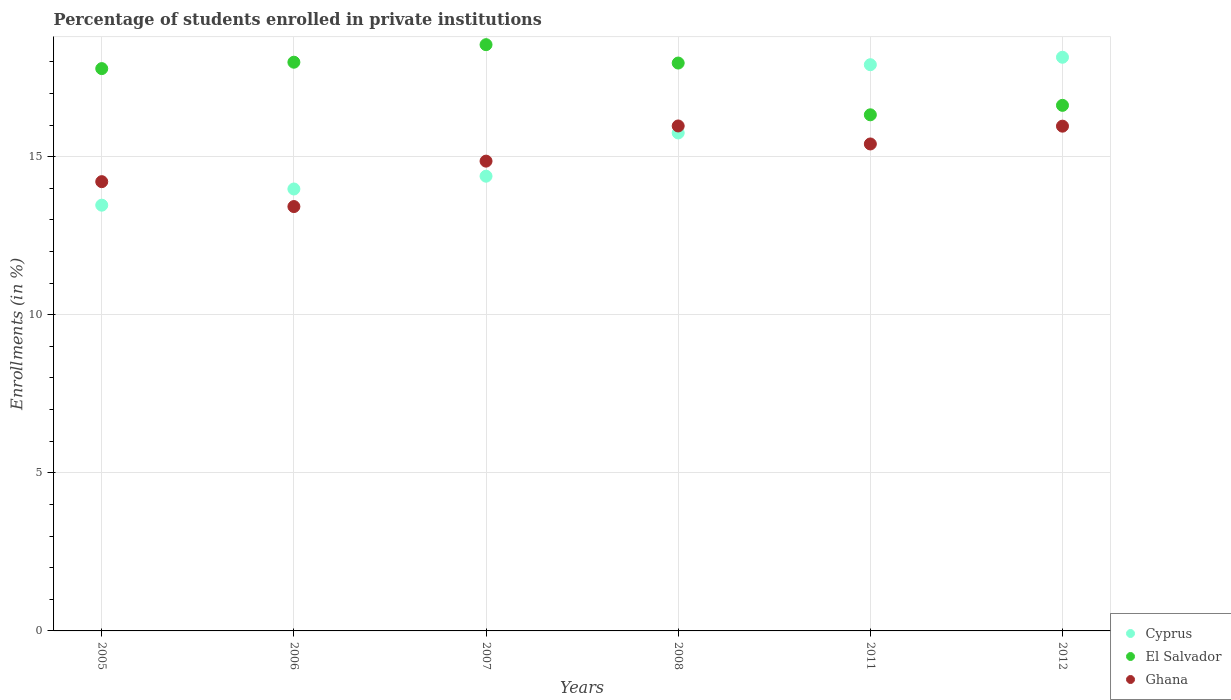How many different coloured dotlines are there?
Give a very brief answer. 3. What is the percentage of trained teachers in Cyprus in 2006?
Keep it short and to the point. 13.98. Across all years, what is the maximum percentage of trained teachers in Ghana?
Offer a terse response. 15.97. Across all years, what is the minimum percentage of trained teachers in El Salvador?
Offer a terse response. 16.32. What is the total percentage of trained teachers in El Salvador in the graph?
Ensure brevity in your answer.  105.23. What is the difference between the percentage of trained teachers in Ghana in 2005 and that in 2007?
Provide a short and direct response. -0.65. What is the difference between the percentage of trained teachers in El Salvador in 2011 and the percentage of trained teachers in Ghana in 2012?
Ensure brevity in your answer.  0.36. What is the average percentage of trained teachers in El Salvador per year?
Your answer should be very brief. 17.54. In the year 2006, what is the difference between the percentage of trained teachers in Ghana and percentage of trained teachers in El Salvador?
Your response must be concise. -4.57. In how many years, is the percentage of trained teachers in Cyprus greater than 13 %?
Your answer should be compact. 6. What is the ratio of the percentage of trained teachers in Ghana in 2006 to that in 2012?
Offer a terse response. 0.84. What is the difference between the highest and the second highest percentage of trained teachers in El Salvador?
Your response must be concise. 0.55. What is the difference between the highest and the lowest percentage of trained teachers in Cyprus?
Keep it short and to the point. 4.68. Is the sum of the percentage of trained teachers in Cyprus in 2007 and 2011 greater than the maximum percentage of trained teachers in El Salvador across all years?
Make the answer very short. Yes. Is it the case that in every year, the sum of the percentage of trained teachers in Cyprus and percentage of trained teachers in Ghana  is greater than the percentage of trained teachers in El Salvador?
Keep it short and to the point. Yes. Is the percentage of trained teachers in El Salvador strictly less than the percentage of trained teachers in Ghana over the years?
Provide a succinct answer. No. How many dotlines are there?
Your response must be concise. 3. What is the difference between two consecutive major ticks on the Y-axis?
Your response must be concise. 5. Where does the legend appear in the graph?
Offer a terse response. Bottom right. What is the title of the graph?
Ensure brevity in your answer.  Percentage of students enrolled in private institutions. Does "Slovak Republic" appear as one of the legend labels in the graph?
Give a very brief answer. No. What is the label or title of the X-axis?
Offer a terse response. Years. What is the label or title of the Y-axis?
Give a very brief answer. Enrollments (in %). What is the Enrollments (in %) in Cyprus in 2005?
Provide a succinct answer. 13.47. What is the Enrollments (in %) of El Salvador in 2005?
Give a very brief answer. 17.79. What is the Enrollments (in %) of Ghana in 2005?
Your answer should be very brief. 14.21. What is the Enrollments (in %) of Cyprus in 2006?
Offer a very short reply. 13.98. What is the Enrollments (in %) in El Salvador in 2006?
Your answer should be very brief. 17.99. What is the Enrollments (in %) in Ghana in 2006?
Provide a short and direct response. 13.42. What is the Enrollments (in %) of Cyprus in 2007?
Keep it short and to the point. 14.38. What is the Enrollments (in %) in El Salvador in 2007?
Give a very brief answer. 18.54. What is the Enrollments (in %) in Ghana in 2007?
Your answer should be very brief. 14.86. What is the Enrollments (in %) of Cyprus in 2008?
Offer a terse response. 15.75. What is the Enrollments (in %) in El Salvador in 2008?
Offer a terse response. 17.96. What is the Enrollments (in %) in Ghana in 2008?
Give a very brief answer. 15.97. What is the Enrollments (in %) in Cyprus in 2011?
Give a very brief answer. 17.91. What is the Enrollments (in %) of El Salvador in 2011?
Provide a succinct answer. 16.32. What is the Enrollments (in %) of Ghana in 2011?
Provide a succinct answer. 15.4. What is the Enrollments (in %) in Cyprus in 2012?
Make the answer very short. 18.15. What is the Enrollments (in %) in El Salvador in 2012?
Give a very brief answer. 16.62. What is the Enrollments (in %) of Ghana in 2012?
Your answer should be very brief. 15.97. Across all years, what is the maximum Enrollments (in %) in Cyprus?
Ensure brevity in your answer.  18.15. Across all years, what is the maximum Enrollments (in %) of El Salvador?
Your answer should be very brief. 18.54. Across all years, what is the maximum Enrollments (in %) in Ghana?
Give a very brief answer. 15.97. Across all years, what is the minimum Enrollments (in %) in Cyprus?
Give a very brief answer. 13.47. Across all years, what is the minimum Enrollments (in %) in El Salvador?
Ensure brevity in your answer.  16.32. Across all years, what is the minimum Enrollments (in %) in Ghana?
Your answer should be compact. 13.42. What is the total Enrollments (in %) in Cyprus in the graph?
Your answer should be very brief. 93.63. What is the total Enrollments (in %) of El Salvador in the graph?
Your answer should be very brief. 105.23. What is the total Enrollments (in %) in Ghana in the graph?
Provide a succinct answer. 89.83. What is the difference between the Enrollments (in %) in Cyprus in 2005 and that in 2006?
Your answer should be compact. -0.51. What is the difference between the Enrollments (in %) of El Salvador in 2005 and that in 2006?
Give a very brief answer. -0.2. What is the difference between the Enrollments (in %) of Ghana in 2005 and that in 2006?
Ensure brevity in your answer.  0.79. What is the difference between the Enrollments (in %) in Cyprus in 2005 and that in 2007?
Provide a short and direct response. -0.92. What is the difference between the Enrollments (in %) of El Salvador in 2005 and that in 2007?
Offer a terse response. -0.76. What is the difference between the Enrollments (in %) in Ghana in 2005 and that in 2007?
Offer a very short reply. -0.65. What is the difference between the Enrollments (in %) of Cyprus in 2005 and that in 2008?
Ensure brevity in your answer.  -2.28. What is the difference between the Enrollments (in %) of El Salvador in 2005 and that in 2008?
Offer a very short reply. -0.18. What is the difference between the Enrollments (in %) in Ghana in 2005 and that in 2008?
Your answer should be compact. -1.76. What is the difference between the Enrollments (in %) in Cyprus in 2005 and that in 2011?
Provide a succinct answer. -4.44. What is the difference between the Enrollments (in %) in El Salvador in 2005 and that in 2011?
Your answer should be very brief. 1.46. What is the difference between the Enrollments (in %) in Ghana in 2005 and that in 2011?
Keep it short and to the point. -1.19. What is the difference between the Enrollments (in %) in Cyprus in 2005 and that in 2012?
Your answer should be compact. -4.68. What is the difference between the Enrollments (in %) in El Salvador in 2005 and that in 2012?
Offer a terse response. 1.16. What is the difference between the Enrollments (in %) in Ghana in 2005 and that in 2012?
Your answer should be very brief. -1.76. What is the difference between the Enrollments (in %) of Cyprus in 2006 and that in 2007?
Give a very brief answer. -0.4. What is the difference between the Enrollments (in %) of El Salvador in 2006 and that in 2007?
Your response must be concise. -0.55. What is the difference between the Enrollments (in %) in Ghana in 2006 and that in 2007?
Ensure brevity in your answer.  -1.44. What is the difference between the Enrollments (in %) of Cyprus in 2006 and that in 2008?
Your response must be concise. -1.77. What is the difference between the Enrollments (in %) of El Salvador in 2006 and that in 2008?
Offer a very short reply. 0.03. What is the difference between the Enrollments (in %) of Ghana in 2006 and that in 2008?
Keep it short and to the point. -2.55. What is the difference between the Enrollments (in %) in Cyprus in 2006 and that in 2011?
Make the answer very short. -3.93. What is the difference between the Enrollments (in %) in El Salvador in 2006 and that in 2011?
Keep it short and to the point. 1.66. What is the difference between the Enrollments (in %) of Ghana in 2006 and that in 2011?
Give a very brief answer. -1.98. What is the difference between the Enrollments (in %) in Cyprus in 2006 and that in 2012?
Provide a short and direct response. -4.17. What is the difference between the Enrollments (in %) in El Salvador in 2006 and that in 2012?
Make the answer very short. 1.36. What is the difference between the Enrollments (in %) of Ghana in 2006 and that in 2012?
Give a very brief answer. -2.54. What is the difference between the Enrollments (in %) in Cyprus in 2007 and that in 2008?
Your response must be concise. -1.37. What is the difference between the Enrollments (in %) in El Salvador in 2007 and that in 2008?
Give a very brief answer. 0.58. What is the difference between the Enrollments (in %) in Ghana in 2007 and that in 2008?
Keep it short and to the point. -1.11. What is the difference between the Enrollments (in %) of Cyprus in 2007 and that in 2011?
Keep it short and to the point. -3.53. What is the difference between the Enrollments (in %) in El Salvador in 2007 and that in 2011?
Offer a very short reply. 2.22. What is the difference between the Enrollments (in %) of Ghana in 2007 and that in 2011?
Make the answer very short. -0.54. What is the difference between the Enrollments (in %) in Cyprus in 2007 and that in 2012?
Provide a short and direct response. -3.76. What is the difference between the Enrollments (in %) of El Salvador in 2007 and that in 2012?
Your answer should be compact. 1.92. What is the difference between the Enrollments (in %) of Ghana in 2007 and that in 2012?
Your answer should be compact. -1.11. What is the difference between the Enrollments (in %) of Cyprus in 2008 and that in 2011?
Provide a succinct answer. -2.16. What is the difference between the Enrollments (in %) of El Salvador in 2008 and that in 2011?
Your answer should be compact. 1.64. What is the difference between the Enrollments (in %) in Ghana in 2008 and that in 2011?
Your response must be concise. 0.57. What is the difference between the Enrollments (in %) of Cyprus in 2008 and that in 2012?
Offer a terse response. -2.39. What is the difference between the Enrollments (in %) of El Salvador in 2008 and that in 2012?
Your answer should be very brief. 1.34. What is the difference between the Enrollments (in %) in Ghana in 2008 and that in 2012?
Offer a very short reply. 0.01. What is the difference between the Enrollments (in %) in Cyprus in 2011 and that in 2012?
Give a very brief answer. -0.24. What is the difference between the Enrollments (in %) of El Salvador in 2011 and that in 2012?
Offer a terse response. -0.3. What is the difference between the Enrollments (in %) of Ghana in 2011 and that in 2012?
Your response must be concise. -0.56. What is the difference between the Enrollments (in %) of Cyprus in 2005 and the Enrollments (in %) of El Salvador in 2006?
Offer a very short reply. -4.52. What is the difference between the Enrollments (in %) in Cyprus in 2005 and the Enrollments (in %) in Ghana in 2006?
Provide a succinct answer. 0.04. What is the difference between the Enrollments (in %) in El Salvador in 2005 and the Enrollments (in %) in Ghana in 2006?
Ensure brevity in your answer.  4.36. What is the difference between the Enrollments (in %) of Cyprus in 2005 and the Enrollments (in %) of El Salvador in 2007?
Provide a succinct answer. -5.08. What is the difference between the Enrollments (in %) in Cyprus in 2005 and the Enrollments (in %) in Ghana in 2007?
Offer a terse response. -1.39. What is the difference between the Enrollments (in %) in El Salvador in 2005 and the Enrollments (in %) in Ghana in 2007?
Your answer should be compact. 2.93. What is the difference between the Enrollments (in %) in Cyprus in 2005 and the Enrollments (in %) in El Salvador in 2008?
Offer a terse response. -4.5. What is the difference between the Enrollments (in %) in Cyprus in 2005 and the Enrollments (in %) in Ghana in 2008?
Your response must be concise. -2.51. What is the difference between the Enrollments (in %) in El Salvador in 2005 and the Enrollments (in %) in Ghana in 2008?
Keep it short and to the point. 1.81. What is the difference between the Enrollments (in %) of Cyprus in 2005 and the Enrollments (in %) of El Salvador in 2011?
Offer a very short reply. -2.86. What is the difference between the Enrollments (in %) of Cyprus in 2005 and the Enrollments (in %) of Ghana in 2011?
Your answer should be compact. -1.94. What is the difference between the Enrollments (in %) in El Salvador in 2005 and the Enrollments (in %) in Ghana in 2011?
Give a very brief answer. 2.38. What is the difference between the Enrollments (in %) of Cyprus in 2005 and the Enrollments (in %) of El Salvador in 2012?
Offer a terse response. -3.16. What is the difference between the Enrollments (in %) in Cyprus in 2005 and the Enrollments (in %) in Ghana in 2012?
Provide a short and direct response. -2.5. What is the difference between the Enrollments (in %) of El Salvador in 2005 and the Enrollments (in %) of Ghana in 2012?
Offer a terse response. 1.82. What is the difference between the Enrollments (in %) in Cyprus in 2006 and the Enrollments (in %) in El Salvador in 2007?
Provide a short and direct response. -4.56. What is the difference between the Enrollments (in %) in Cyprus in 2006 and the Enrollments (in %) in Ghana in 2007?
Provide a short and direct response. -0.88. What is the difference between the Enrollments (in %) of El Salvador in 2006 and the Enrollments (in %) of Ghana in 2007?
Ensure brevity in your answer.  3.13. What is the difference between the Enrollments (in %) in Cyprus in 2006 and the Enrollments (in %) in El Salvador in 2008?
Keep it short and to the point. -3.98. What is the difference between the Enrollments (in %) of Cyprus in 2006 and the Enrollments (in %) of Ghana in 2008?
Make the answer very short. -1.99. What is the difference between the Enrollments (in %) in El Salvador in 2006 and the Enrollments (in %) in Ghana in 2008?
Ensure brevity in your answer.  2.02. What is the difference between the Enrollments (in %) in Cyprus in 2006 and the Enrollments (in %) in El Salvador in 2011?
Offer a very short reply. -2.35. What is the difference between the Enrollments (in %) of Cyprus in 2006 and the Enrollments (in %) of Ghana in 2011?
Give a very brief answer. -1.42. What is the difference between the Enrollments (in %) of El Salvador in 2006 and the Enrollments (in %) of Ghana in 2011?
Your answer should be very brief. 2.59. What is the difference between the Enrollments (in %) of Cyprus in 2006 and the Enrollments (in %) of El Salvador in 2012?
Ensure brevity in your answer.  -2.65. What is the difference between the Enrollments (in %) of Cyprus in 2006 and the Enrollments (in %) of Ghana in 2012?
Your answer should be compact. -1.99. What is the difference between the Enrollments (in %) of El Salvador in 2006 and the Enrollments (in %) of Ghana in 2012?
Your answer should be compact. 2.02. What is the difference between the Enrollments (in %) in Cyprus in 2007 and the Enrollments (in %) in El Salvador in 2008?
Provide a succinct answer. -3.58. What is the difference between the Enrollments (in %) of Cyprus in 2007 and the Enrollments (in %) of Ghana in 2008?
Give a very brief answer. -1.59. What is the difference between the Enrollments (in %) of El Salvador in 2007 and the Enrollments (in %) of Ghana in 2008?
Ensure brevity in your answer.  2.57. What is the difference between the Enrollments (in %) of Cyprus in 2007 and the Enrollments (in %) of El Salvador in 2011?
Provide a short and direct response. -1.94. What is the difference between the Enrollments (in %) in Cyprus in 2007 and the Enrollments (in %) in Ghana in 2011?
Your answer should be very brief. -1.02. What is the difference between the Enrollments (in %) in El Salvador in 2007 and the Enrollments (in %) in Ghana in 2011?
Provide a succinct answer. 3.14. What is the difference between the Enrollments (in %) of Cyprus in 2007 and the Enrollments (in %) of El Salvador in 2012?
Your response must be concise. -2.24. What is the difference between the Enrollments (in %) in Cyprus in 2007 and the Enrollments (in %) in Ghana in 2012?
Your response must be concise. -1.58. What is the difference between the Enrollments (in %) in El Salvador in 2007 and the Enrollments (in %) in Ghana in 2012?
Give a very brief answer. 2.58. What is the difference between the Enrollments (in %) in Cyprus in 2008 and the Enrollments (in %) in El Salvador in 2011?
Give a very brief answer. -0.57. What is the difference between the Enrollments (in %) of Cyprus in 2008 and the Enrollments (in %) of Ghana in 2011?
Your answer should be very brief. 0.35. What is the difference between the Enrollments (in %) in El Salvador in 2008 and the Enrollments (in %) in Ghana in 2011?
Offer a very short reply. 2.56. What is the difference between the Enrollments (in %) of Cyprus in 2008 and the Enrollments (in %) of El Salvador in 2012?
Provide a short and direct response. -0.87. What is the difference between the Enrollments (in %) in Cyprus in 2008 and the Enrollments (in %) in Ghana in 2012?
Your answer should be very brief. -0.21. What is the difference between the Enrollments (in %) of El Salvador in 2008 and the Enrollments (in %) of Ghana in 2012?
Make the answer very short. 2. What is the difference between the Enrollments (in %) in Cyprus in 2011 and the Enrollments (in %) in El Salvador in 2012?
Provide a short and direct response. 1.29. What is the difference between the Enrollments (in %) of Cyprus in 2011 and the Enrollments (in %) of Ghana in 2012?
Your answer should be very brief. 1.94. What is the difference between the Enrollments (in %) in El Salvador in 2011 and the Enrollments (in %) in Ghana in 2012?
Offer a very short reply. 0.36. What is the average Enrollments (in %) in Cyprus per year?
Your response must be concise. 15.61. What is the average Enrollments (in %) of El Salvador per year?
Provide a short and direct response. 17.54. What is the average Enrollments (in %) in Ghana per year?
Your answer should be very brief. 14.97. In the year 2005, what is the difference between the Enrollments (in %) of Cyprus and Enrollments (in %) of El Salvador?
Provide a succinct answer. -4.32. In the year 2005, what is the difference between the Enrollments (in %) of Cyprus and Enrollments (in %) of Ghana?
Your answer should be compact. -0.74. In the year 2005, what is the difference between the Enrollments (in %) of El Salvador and Enrollments (in %) of Ghana?
Ensure brevity in your answer.  3.58. In the year 2006, what is the difference between the Enrollments (in %) in Cyprus and Enrollments (in %) in El Salvador?
Give a very brief answer. -4.01. In the year 2006, what is the difference between the Enrollments (in %) in Cyprus and Enrollments (in %) in Ghana?
Provide a short and direct response. 0.56. In the year 2006, what is the difference between the Enrollments (in %) of El Salvador and Enrollments (in %) of Ghana?
Ensure brevity in your answer.  4.57. In the year 2007, what is the difference between the Enrollments (in %) in Cyprus and Enrollments (in %) in El Salvador?
Provide a succinct answer. -4.16. In the year 2007, what is the difference between the Enrollments (in %) in Cyprus and Enrollments (in %) in Ghana?
Your answer should be compact. -0.48. In the year 2007, what is the difference between the Enrollments (in %) of El Salvador and Enrollments (in %) of Ghana?
Give a very brief answer. 3.68. In the year 2008, what is the difference between the Enrollments (in %) in Cyprus and Enrollments (in %) in El Salvador?
Offer a terse response. -2.21. In the year 2008, what is the difference between the Enrollments (in %) in Cyprus and Enrollments (in %) in Ghana?
Ensure brevity in your answer.  -0.22. In the year 2008, what is the difference between the Enrollments (in %) of El Salvador and Enrollments (in %) of Ghana?
Ensure brevity in your answer.  1.99. In the year 2011, what is the difference between the Enrollments (in %) of Cyprus and Enrollments (in %) of El Salvador?
Keep it short and to the point. 1.58. In the year 2011, what is the difference between the Enrollments (in %) of Cyprus and Enrollments (in %) of Ghana?
Your answer should be compact. 2.51. In the year 2011, what is the difference between the Enrollments (in %) of El Salvador and Enrollments (in %) of Ghana?
Your answer should be compact. 0.92. In the year 2012, what is the difference between the Enrollments (in %) of Cyprus and Enrollments (in %) of El Salvador?
Your answer should be compact. 1.52. In the year 2012, what is the difference between the Enrollments (in %) in Cyprus and Enrollments (in %) in Ghana?
Give a very brief answer. 2.18. In the year 2012, what is the difference between the Enrollments (in %) of El Salvador and Enrollments (in %) of Ghana?
Your response must be concise. 0.66. What is the ratio of the Enrollments (in %) in Cyprus in 2005 to that in 2006?
Offer a very short reply. 0.96. What is the ratio of the Enrollments (in %) of Ghana in 2005 to that in 2006?
Keep it short and to the point. 1.06. What is the ratio of the Enrollments (in %) in Cyprus in 2005 to that in 2007?
Give a very brief answer. 0.94. What is the ratio of the Enrollments (in %) in El Salvador in 2005 to that in 2007?
Your response must be concise. 0.96. What is the ratio of the Enrollments (in %) of Ghana in 2005 to that in 2007?
Give a very brief answer. 0.96. What is the ratio of the Enrollments (in %) of Cyprus in 2005 to that in 2008?
Keep it short and to the point. 0.85. What is the ratio of the Enrollments (in %) in El Salvador in 2005 to that in 2008?
Your response must be concise. 0.99. What is the ratio of the Enrollments (in %) in Ghana in 2005 to that in 2008?
Ensure brevity in your answer.  0.89. What is the ratio of the Enrollments (in %) in Cyprus in 2005 to that in 2011?
Your response must be concise. 0.75. What is the ratio of the Enrollments (in %) in El Salvador in 2005 to that in 2011?
Your answer should be compact. 1.09. What is the ratio of the Enrollments (in %) of Ghana in 2005 to that in 2011?
Make the answer very short. 0.92. What is the ratio of the Enrollments (in %) in Cyprus in 2005 to that in 2012?
Ensure brevity in your answer.  0.74. What is the ratio of the Enrollments (in %) of El Salvador in 2005 to that in 2012?
Make the answer very short. 1.07. What is the ratio of the Enrollments (in %) in Ghana in 2005 to that in 2012?
Your response must be concise. 0.89. What is the ratio of the Enrollments (in %) in Cyprus in 2006 to that in 2007?
Ensure brevity in your answer.  0.97. What is the ratio of the Enrollments (in %) in El Salvador in 2006 to that in 2007?
Your answer should be very brief. 0.97. What is the ratio of the Enrollments (in %) of Ghana in 2006 to that in 2007?
Offer a terse response. 0.9. What is the ratio of the Enrollments (in %) of Cyprus in 2006 to that in 2008?
Your answer should be very brief. 0.89. What is the ratio of the Enrollments (in %) of Ghana in 2006 to that in 2008?
Make the answer very short. 0.84. What is the ratio of the Enrollments (in %) of Cyprus in 2006 to that in 2011?
Provide a succinct answer. 0.78. What is the ratio of the Enrollments (in %) in El Salvador in 2006 to that in 2011?
Keep it short and to the point. 1.1. What is the ratio of the Enrollments (in %) of Ghana in 2006 to that in 2011?
Offer a very short reply. 0.87. What is the ratio of the Enrollments (in %) in Cyprus in 2006 to that in 2012?
Make the answer very short. 0.77. What is the ratio of the Enrollments (in %) of El Salvador in 2006 to that in 2012?
Keep it short and to the point. 1.08. What is the ratio of the Enrollments (in %) of Ghana in 2006 to that in 2012?
Ensure brevity in your answer.  0.84. What is the ratio of the Enrollments (in %) in Cyprus in 2007 to that in 2008?
Your response must be concise. 0.91. What is the ratio of the Enrollments (in %) in El Salvador in 2007 to that in 2008?
Provide a short and direct response. 1.03. What is the ratio of the Enrollments (in %) of Ghana in 2007 to that in 2008?
Keep it short and to the point. 0.93. What is the ratio of the Enrollments (in %) in Cyprus in 2007 to that in 2011?
Your answer should be very brief. 0.8. What is the ratio of the Enrollments (in %) in El Salvador in 2007 to that in 2011?
Your response must be concise. 1.14. What is the ratio of the Enrollments (in %) of Ghana in 2007 to that in 2011?
Provide a succinct answer. 0.96. What is the ratio of the Enrollments (in %) in Cyprus in 2007 to that in 2012?
Give a very brief answer. 0.79. What is the ratio of the Enrollments (in %) of El Salvador in 2007 to that in 2012?
Keep it short and to the point. 1.12. What is the ratio of the Enrollments (in %) of Ghana in 2007 to that in 2012?
Your response must be concise. 0.93. What is the ratio of the Enrollments (in %) in Cyprus in 2008 to that in 2011?
Provide a short and direct response. 0.88. What is the ratio of the Enrollments (in %) of El Salvador in 2008 to that in 2011?
Your answer should be very brief. 1.1. What is the ratio of the Enrollments (in %) of Ghana in 2008 to that in 2011?
Your answer should be very brief. 1.04. What is the ratio of the Enrollments (in %) in Cyprus in 2008 to that in 2012?
Provide a succinct answer. 0.87. What is the ratio of the Enrollments (in %) of El Salvador in 2008 to that in 2012?
Make the answer very short. 1.08. What is the ratio of the Enrollments (in %) in Ghana in 2008 to that in 2012?
Your response must be concise. 1. What is the ratio of the Enrollments (in %) of Cyprus in 2011 to that in 2012?
Offer a very short reply. 0.99. What is the ratio of the Enrollments (in %) of El Salvador in 2011 to that in 2012?
Make the answer very short. 0.98. What is the ratio of the Enrollments (in %) in Ghana in 2011 to that in 2012?
Make the answer very short. 0.96. What is the difference between the highest and the second highest Enrollments (in %) of Cyprus?
Keep it short and to the point. 0.24. What is the difference between the highest and the second highest Enrollments (in %) in El Salvador?
Your answer should be compact. 0.55. What is the difference between the highest and the second highest Enrollments (in %) in Ghana?
Offer a terse response. 0.01. What is the difference between the highest and the lowest Enrollments (in %) of Cyprus?
Offer a very short reply. 4.68. What is the difference between the highest and the lowest Enrollments (in %) of El Salvador?
Offer a terse response. 2.22. What is the difference between the highest and the lowest Enrollments (in %) of Ghana?
Your response must be concise. 2.55. 